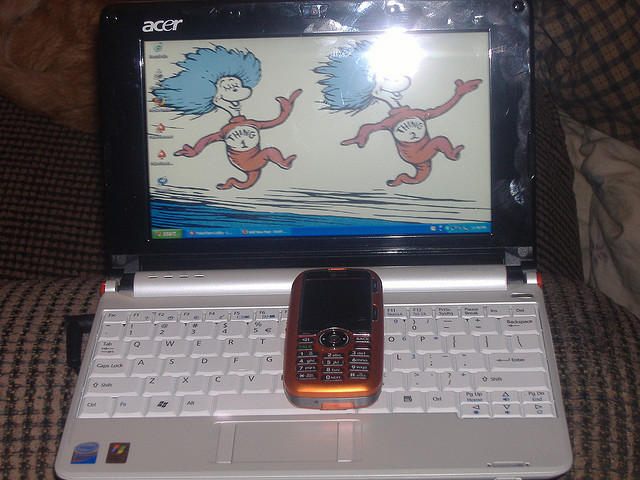Read all the text in this image. acer THING 2 THING 1 Caps Lock Tab Esc Shift Ctrl Alt Q A Z X S W E 0 C V F G R T 1 2 9 I 5 0 O P L Enter Shift Ctrl Pg up Pg Dn Back space F2 